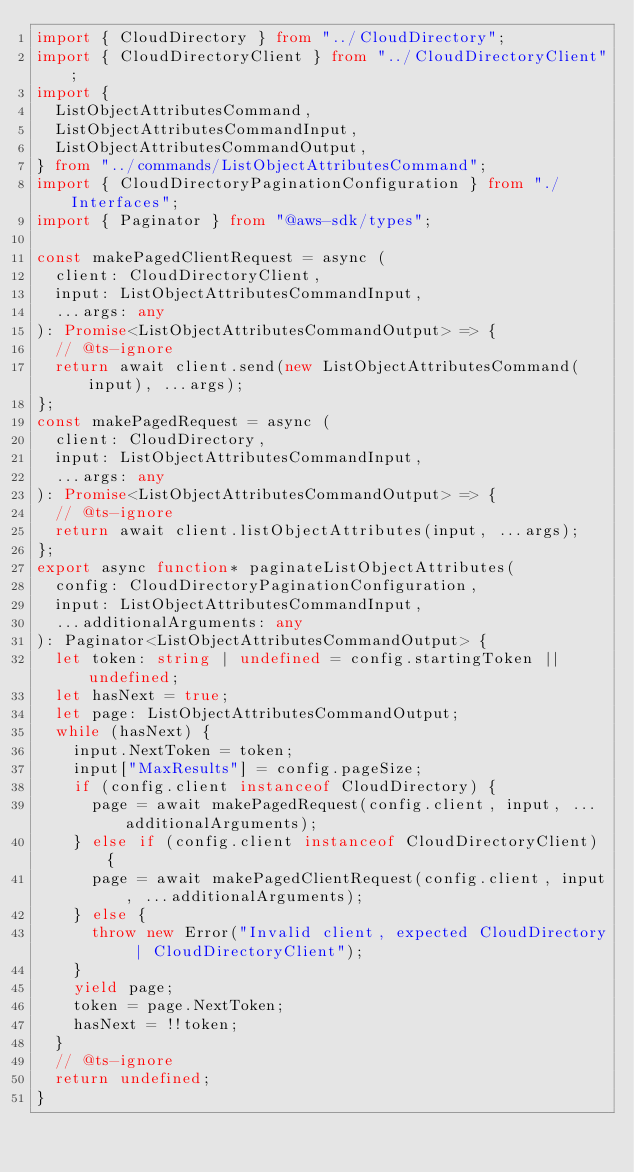Convert code to text. <code><loc_0><loc_0><loc_500><loc_500><_TypeScript_>import { CloudDirectory } from "../CloudDirectory";
import { CloudDirectoryClient } from "../CloudDirectoryClient";
import {
  ListObjectAttributesCommand,
  ListObjectAttributesCommandInput,
  ListObjectAttributesCommandOutput,
} from "../commands/ListObjectAttributesCommand";
import { CloudDirectoryPaginationConfiguration } from "./Interfaces";
import { Paginator } from "@aws-sdk/types";

const makePagedClientRequest = async (
  client: CloudDirectoryClient,
  input: ListObjectAttributesCommandInput,
  ...args: any
): Promise<ListObjectAttributesCommandOutput> => {
  // @ts-ignore
  return await client.send(new ListObjectAttributesCommand(input), ...args);
};
const makePagedRequest = async (
  client: CloudDirectory,
  input: ListObjectAttributesCommandInput,
  ...args: any
): Promise<ListObjectAttributesCommandOutput> => {
  // @ts-ignore
  return await client.listObjectAttributes(input, ...args);
};
export async function* paginateListObjectAttributes(
  config: CloudDirectoryPaginationConfiguration,
  input: ListObjectAttributesCommandInput,
  ...additionalArguments: any
): Paginator<ListObjectAttributesCommandOutput> {
  let token: string | undefined = config.startingToken || undefined;
  let hasNext = true;
  let page: ListObjectAttributesCommandOutput;
  while (hasNext) {
    input.NextToken = token;
    input["MaxResults"] = config.pageSize;
    if (config.client instanceof CloudDirectory) {
      page = await makePagedRequest(config.client, input, ...additionalArguments);
    } else if (config.client instanceof CloudDirectoryClient) {
      page = await makePagedClientRequest(config.client, input, ...additionalArguments);
    } else {
      throw new Error("Invalid client, expected CloudDirectory | CloudDirectoryClient");
    }
    yield page;
    token = page.NextToken;
    hasNext = !!token;
  }
  // @ts-ignore
  return undefined;
}
</code> 